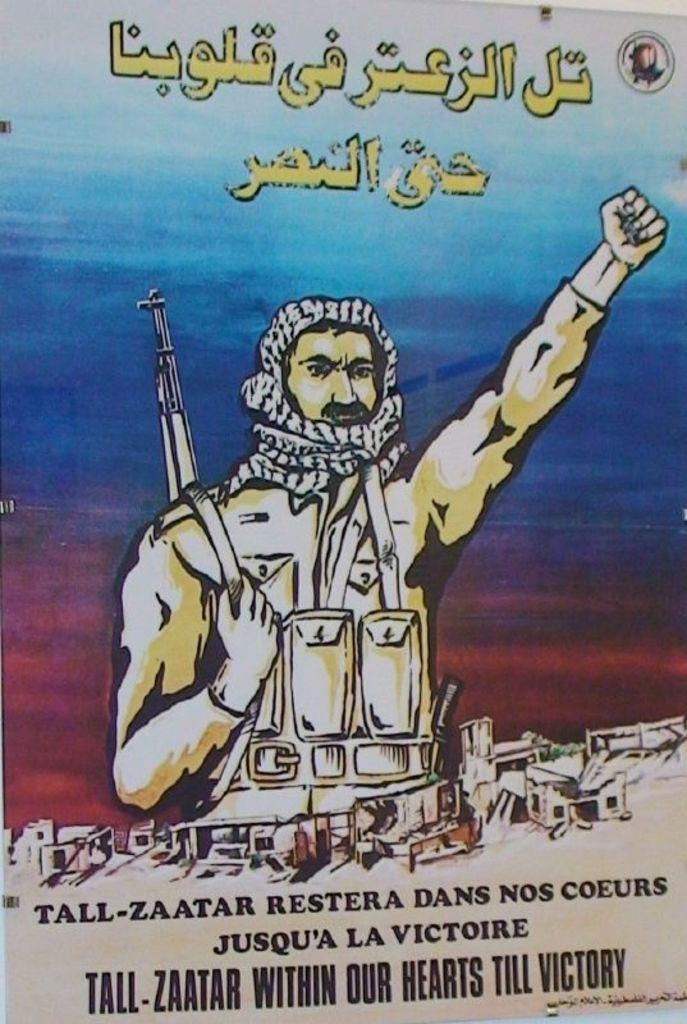<image>
Provide a brief description of the given image. An illustrated poster shows a soldier with a gun over his shoulder and Tall Zaatar within our hearts till victory at the bottom. 